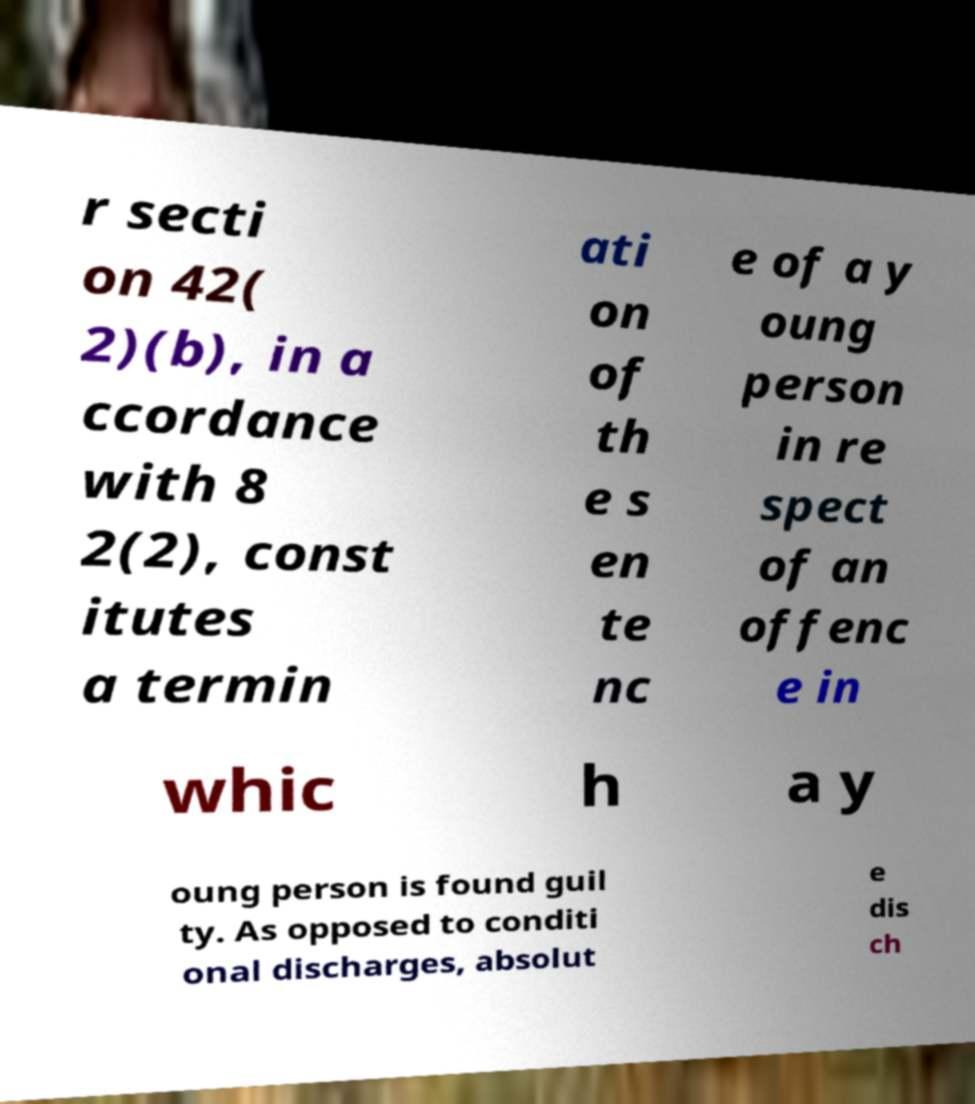Can you read and provide the text displayed in the image?This photo seems to have some interesting text. Can you extract and type it out for me? r secti on 42( 2)(b), in a ccordance with 8 2(2), const itutes a termin ati on of th e s en te nc e of a y oung person in re spect of an offenc e in whic h a y oung person is found guil ty. As opposed to conditi onal discharges, absolut e dis ch 